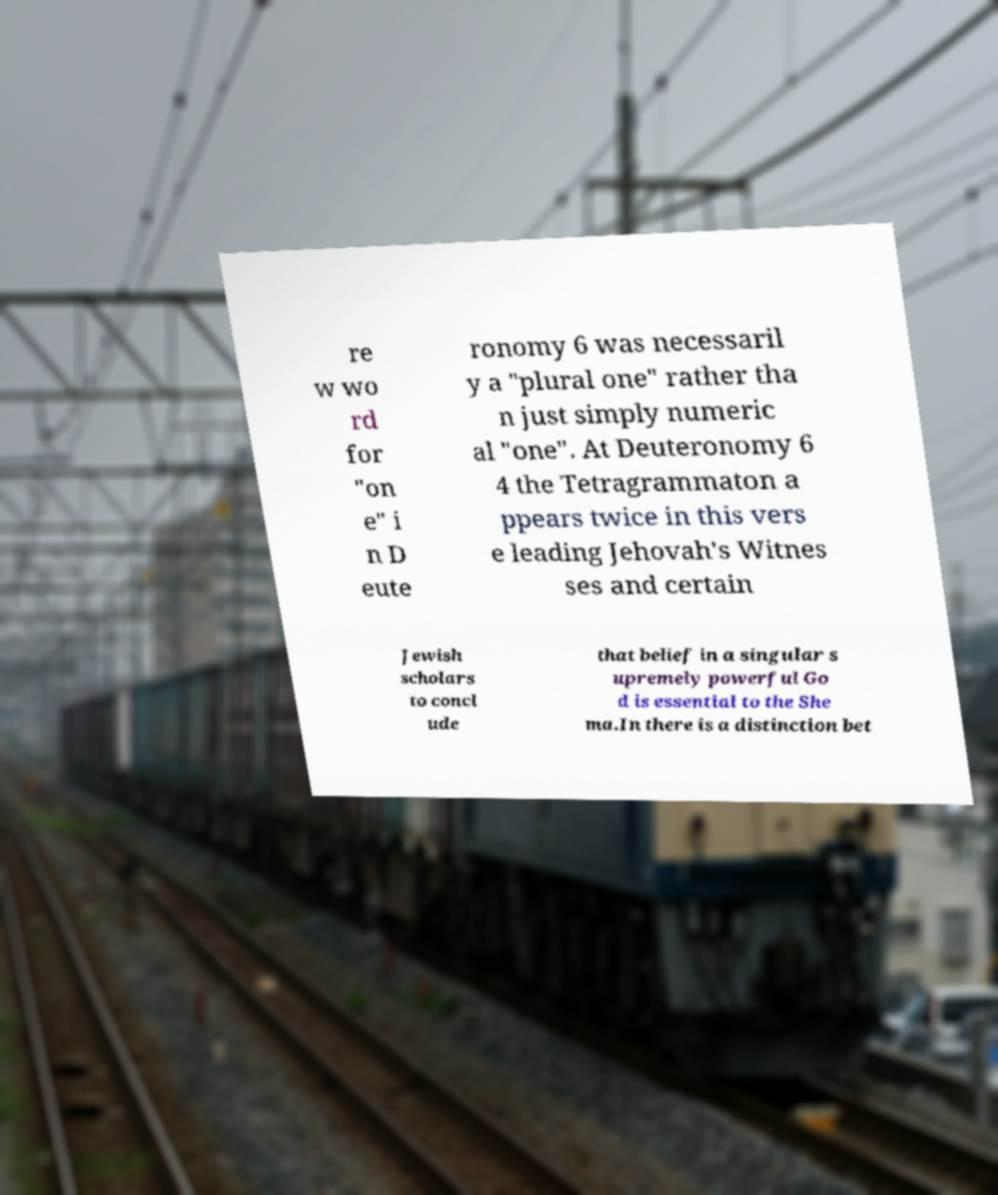What messages or text are displayed in this image? I need them in a readable, typed format. re w wo rd for "on e" i n D eute ronomy 6 was necessaril y a "plural one" rather tha n just simply numeric al "one". At Deuteronomy 6 4 the Tetragrammaton a ppears twice in this vers e leading Jehovah's Witnes ses and certain Jewish scholars to concl ude that belief in a singular s upremely powerful Go d is essential to the She ma.In there is a distinction bet 